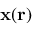<formula> <loc_0><loc_0><loc_500><loc_500>x ( r )</formula> 